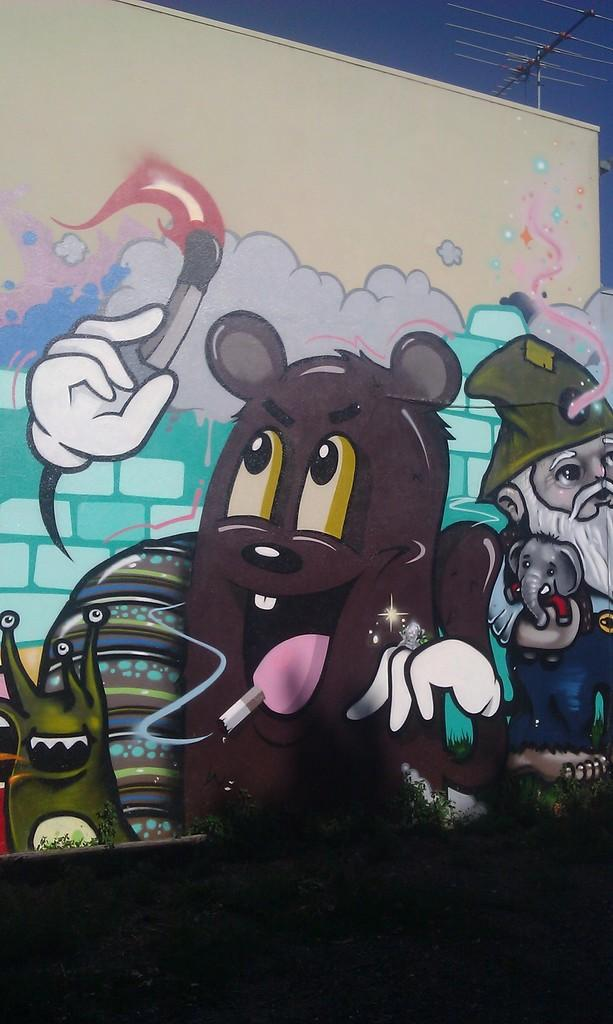What type of artwork is on the wall in the image? There are multicolor paintings on the wall in the image. What color is the wall? The wall is in cream color. What can be seen in the background of the image? The sky is visible in the background of the image. What color is the sky? The sky is in blue color. Can you see any dinosaurs in the image? No, there are no dinosaurs present in the image. How many fingers does the painting have? The provided facts do not mention any fingers in the image, as the focus is on the wall and the sky. 